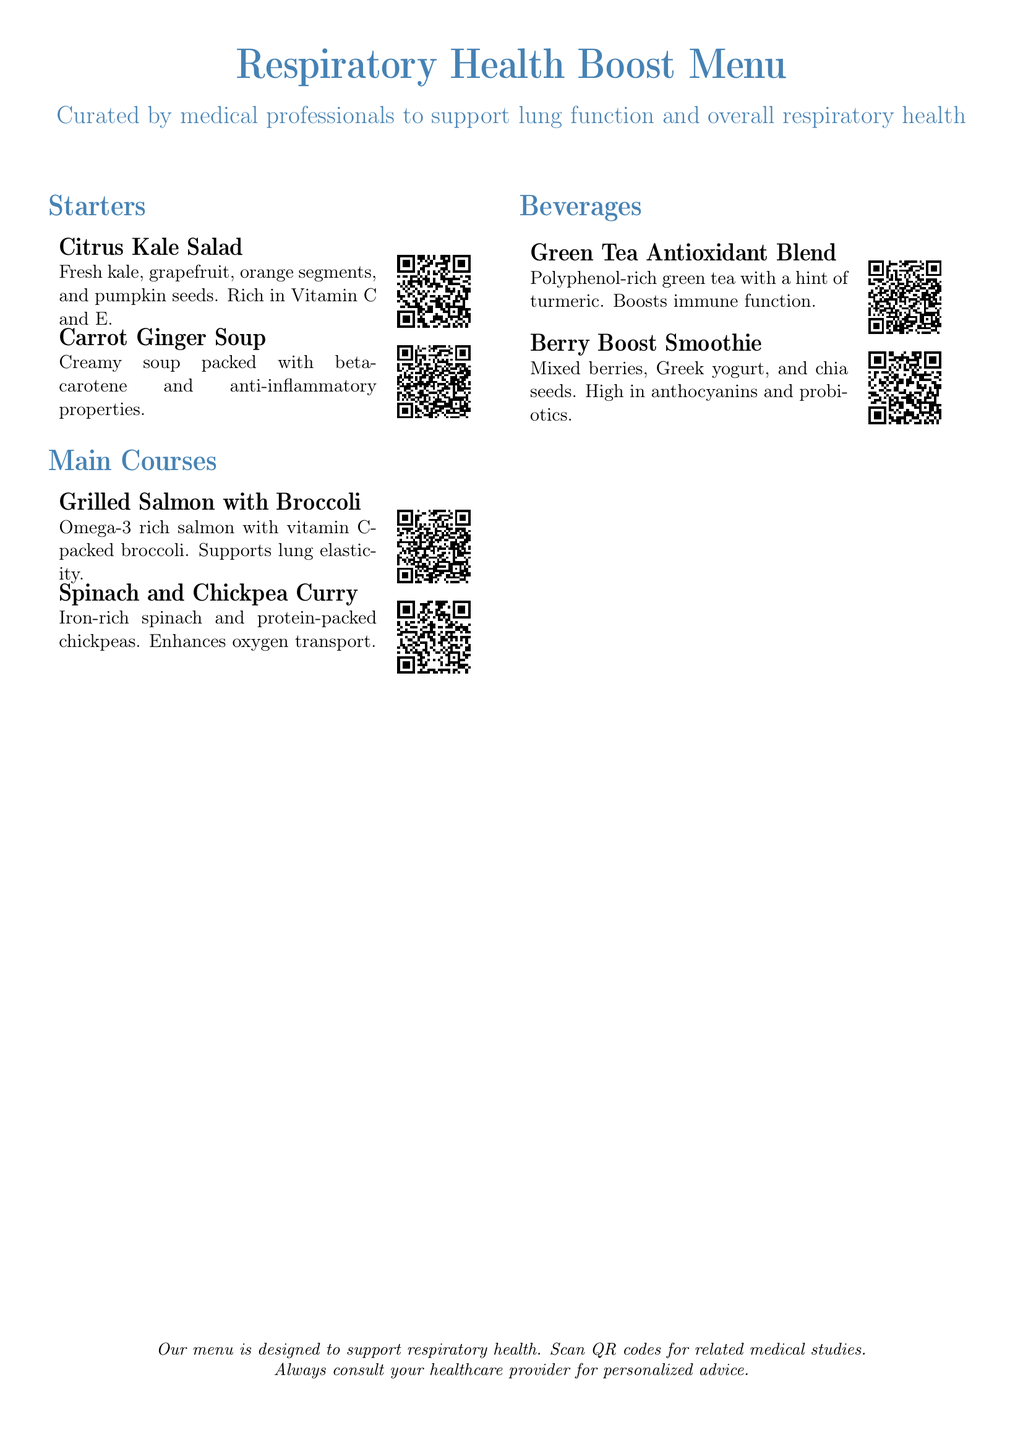What is the title of the menu? The title of the menu is prominently displayed at the top of the document, which is designed to highlight its focus on lung health.
Answer: Respiratory Health Boost Menu How many starters are listed? The document enumerates the sections, revealing the number of items included in each section.
Answer: 2 Which dish contains omega-3? The menu specifies details regarding each main course, providing nutritional information about them.
Answer: Grilled Salmon with Broccoli What vitamin is highlighted in the Citrus Kale Salad? The menu mentions specific vitamins associated with each dish, particularly in the starters section.
Answer: Vitamin C and E What type of tea is offered? The beverages section categorically describes each drink, including their primary ingredients.
Answer: Green Tea Antioxidant Blend Which item is packed with beta-carotene? The contents of each dish are listed, providing insights into their key nutritional components.
Answer: Carrot Ginger Soup What health benefit is associated with the Berry Boost Smoothie? The menu identifies the health benefits related to the ingredients of each beverage.
Answer: Probiotics What’s the QR code for? The document includes a note describing the function of the QR codes related to the items.
Answer: Related medical studies 